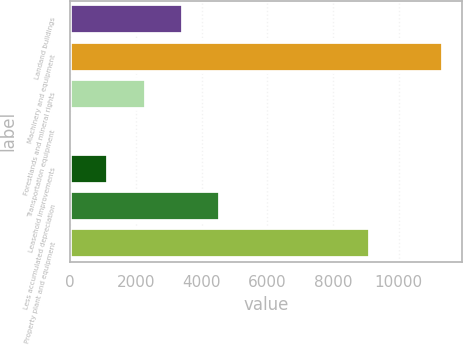<chart> <loc_0><loc_0><loc_500><loc_500><bar_chart><fcel>Landand buildings<fcel>Machinery and equipment<fcel>Forestlands and mineral rights<fcel>Transportation equipment<fcel>Leasehold improvements<fcel>Less accumulated depreciation<fcel>Property plant and equipment<nl><fcel>3426.4<fcel>11349.7<fcel>2294.5<fcel>30.7<fcel>1162.6<fcel>4564.2<fcel>9118.3<nl></chart> 